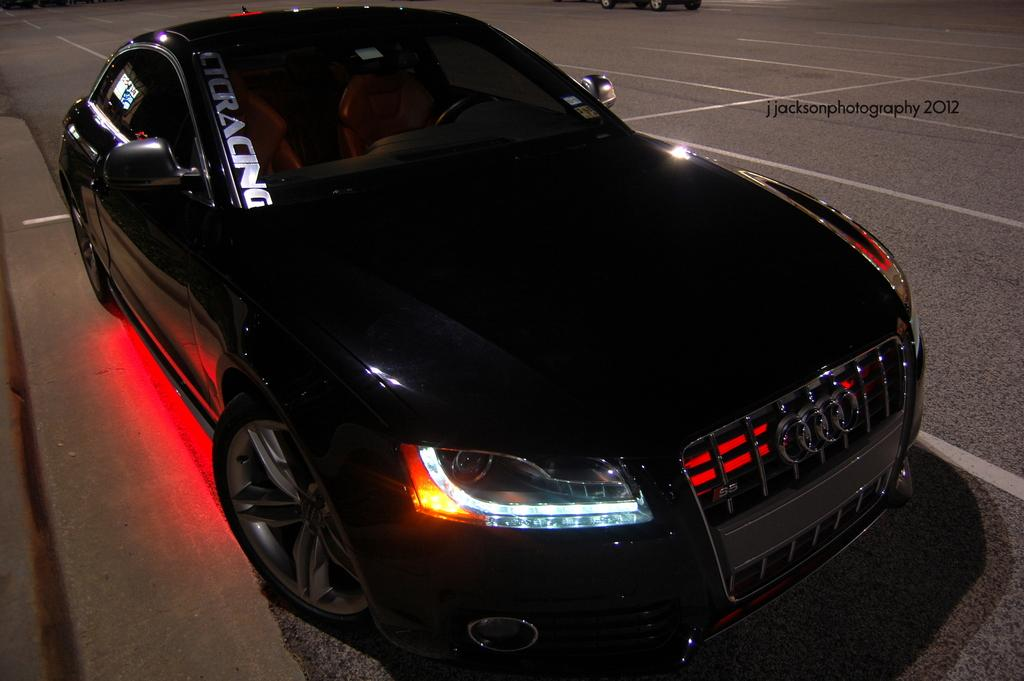What is the main subject of the image? The main subject of the image is a car. What colors can be seen on the car? The car is black and red in color. Where is the car located in the image? The car is on the road. What can be seen in the background of the image? There is another car on the road in the background. What type of cork can be seen in the image? There is no cork present in the image. How does the car express regret in the image? Cars do not have the ability to express emotions like regret, so this cannot be observed in the image. 